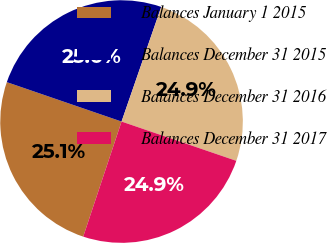Convert chart to OTSL. <chart><loc_0><loc_0><loc_500><loc_500><pie_chart><fcel>Balances January 1 2015<fcel>Balances December 31 2015<fcel>Balances December 31 2016<fcel>Balances December 31 2017<nl><fcel>25.15%<fcel>25.04%<fcel>24.95%<fcel>24.87%<nl></chart> 